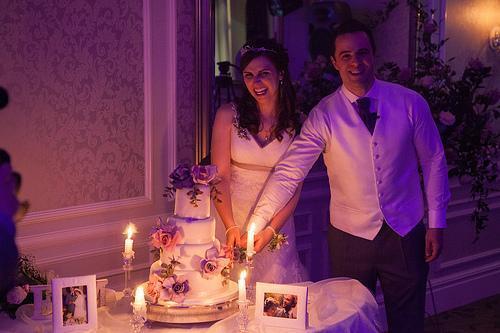How many people are there?
Give a very brief answer. 2. 